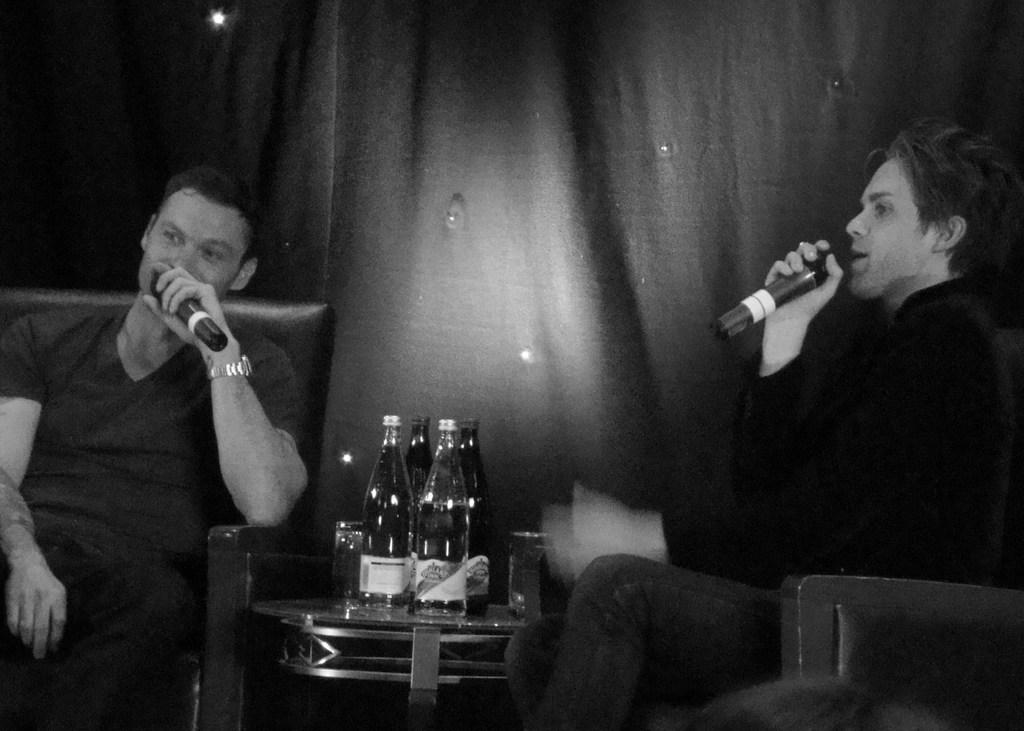How many people are present in the image? There are two people seated in the image. What are the people doing in the image? The people are talking using microphones. What type of furniture is present in the image? There are chairs in the image. What can be seen on the table in the image? There are bottles on a table in the image. Can you see a stranger walking towards the people with a sail in the image? No, there is no stranger or sail present in the image. 